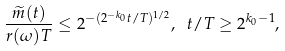<formula> <loc_0><loc_0><loc_500><loc_500>\frac { \widetilde { m } ( t ) } { r ( \omega ) T } \leq 2 ^ { - ( 2 ^ { - k _ { 0 } } t / T ) ^ { 1 / 2 } } , \ t / T \geq 2 ^ { k _ { 0 } - 1 } ,</formula> 